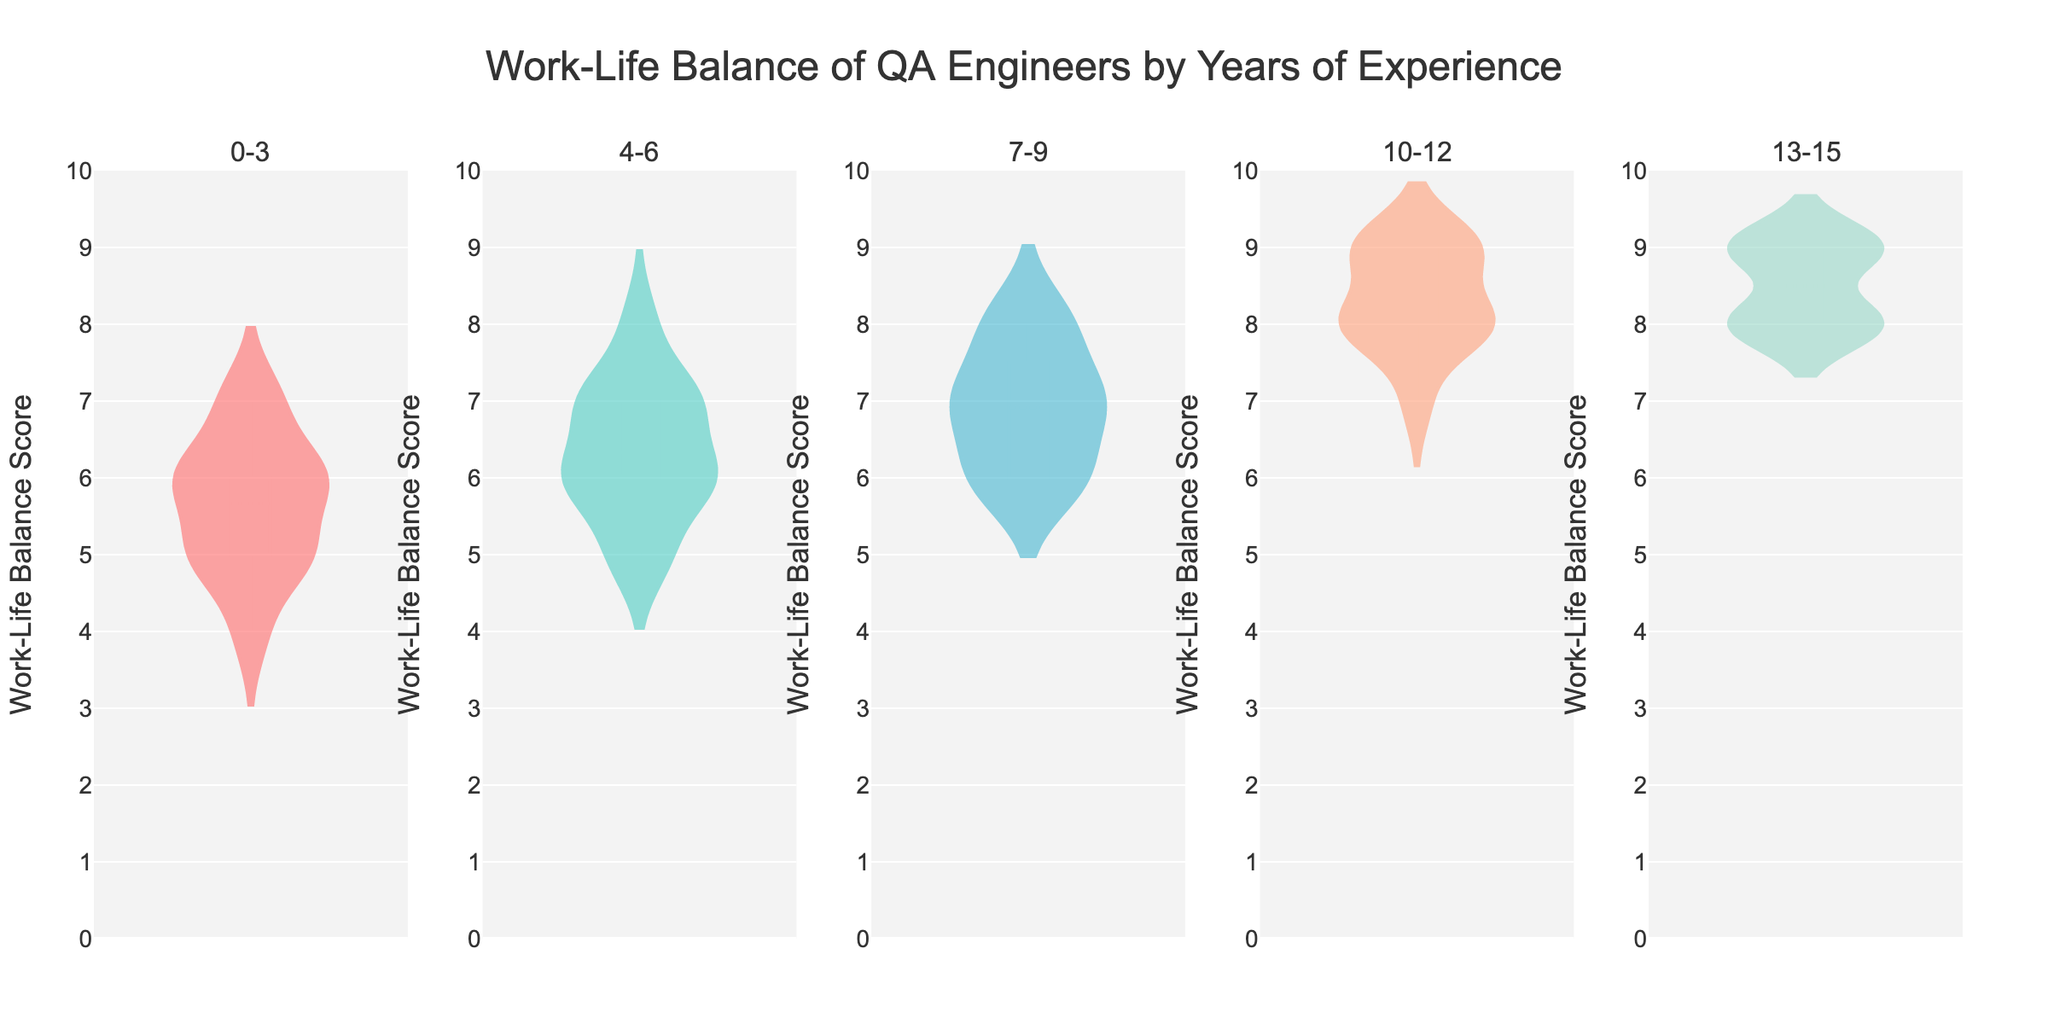What's the title of the figure? The title of the figure is found at the top and reads "Work-Life Balance of QA Engineers by Years of Experience".
Answer: Work-Life Balance of QA Engineers by Years of Experience Which experience group has the highest median work-life balance score? From the violin plots, the group "13-15" shows the median line (white dot) at the highest position.
Answer: 13-15 What is the range of the y-axis? The y-axis range is visible on the left as it spans from 0 to 10.
Answer: 0 to 10 How does the work-life balance score for the "0-3" experience group compare to the "10-12" experience group in terms of spread? Observing both violin plots, the "0-3" experience group has a narrower spread, indicating less variability, whereas the "10-12" group shows a wider spread of data points indicating greater variability.
Answer: "0-3" has less spread than "10-12" Which experience group has the smallest spread in their work-life balance scores? The "7-9" experience group shows the smallest spread since the data is tightly clustered around the center.
Answer: 7-9 What central tendency measurement is represented by the white dot in the violin plots? The white dot in the violin plots represents the median of the work-life balance scores for each experience group.
Answer: Median What experience group has the most symmetrical distribution of work-life balance scores? Observing the symmetry of the plots, "7-9" and "13-15" experience groups seem to have the most balanced distributions.
Answer: 7-9 and 13-15 Which groups have data points consistently reaching the highest scores? The violin plots for groups "10-12" and "13-15" show data points approaching the score of 9.
Answer: 10-12 and 13-15 Is there a visible trend in work-life balance scores as years of experience increase? Based on the medians and spreads, work-life balance scores generally appear to increase with experience, reaching higher medians in the groups "10-12" and "13-15".
Answer: Work-life balance scores increase with experience What is the annotation at the bottom of the figure? The annotation states, "Based on survey data from QA engineers" and it’s found below the x-axis.
Answer: Based on survey data from QA engineers 